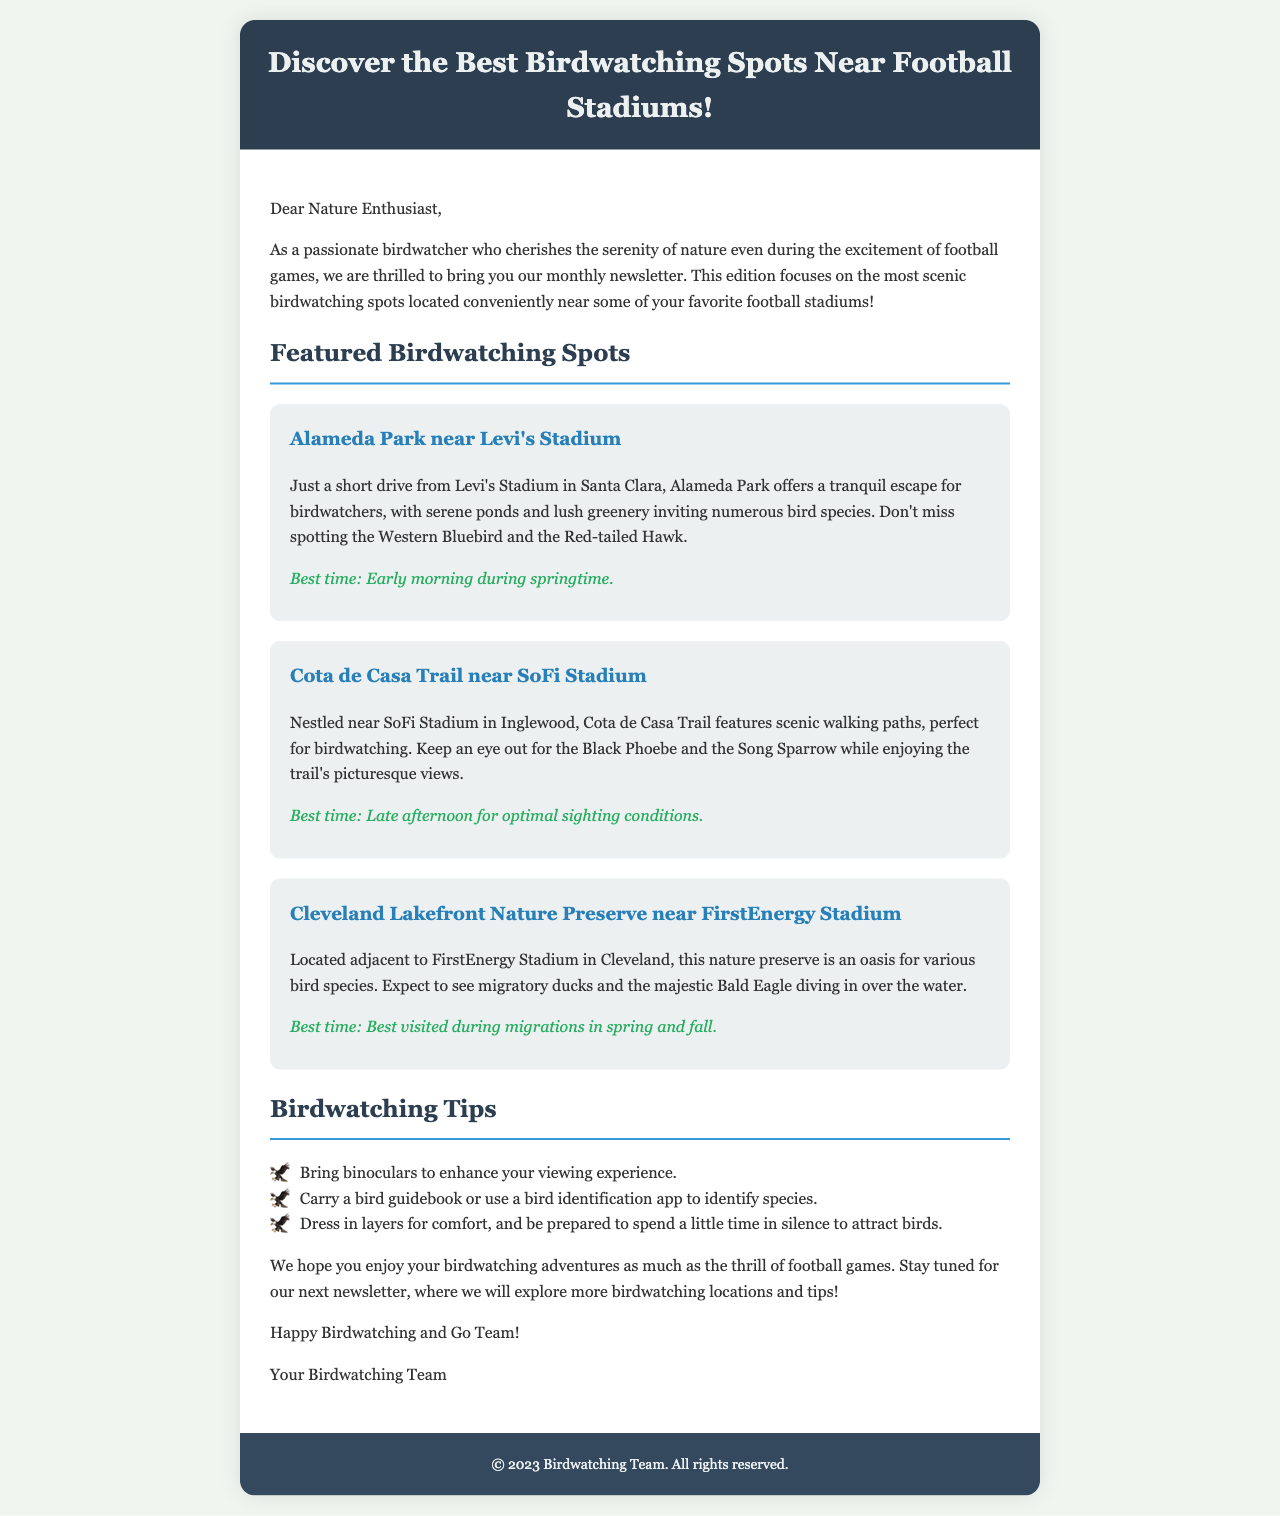What is the title of the newsletter? The title of the newsletter is indicated in the header section of the document.
Answer: Discover the Best Birdwatching Spots Near Football Stadiums! What is one bird species mentioned near Alameda Park? The document lists specific bird species near each featured spot, including those near Alameda Park.
Answer: Western Bluebird What is the best time to visit Cota de Casa Trail? The best time for birdwatching at each spot is specified in the description of each featured location.
Answer: Late afternoon for optimal sighting conditions Which football stadium is near Cleveland Lakefront Nature Preserve? The locations of the featured spots are listed along with their proximity to specific football stadiums.
Answer: FirstEnergy Stadium What type of tips are provided in the newsletter? The document includes a section on tips specifically aimed at enhancing the birdwatching experience.
Answer: Birdwatching Tips How many featured birdwatching spots are listed in the newsletter? The number of spots is determined by counting the number of featured sections in the document.
Answer: Three 